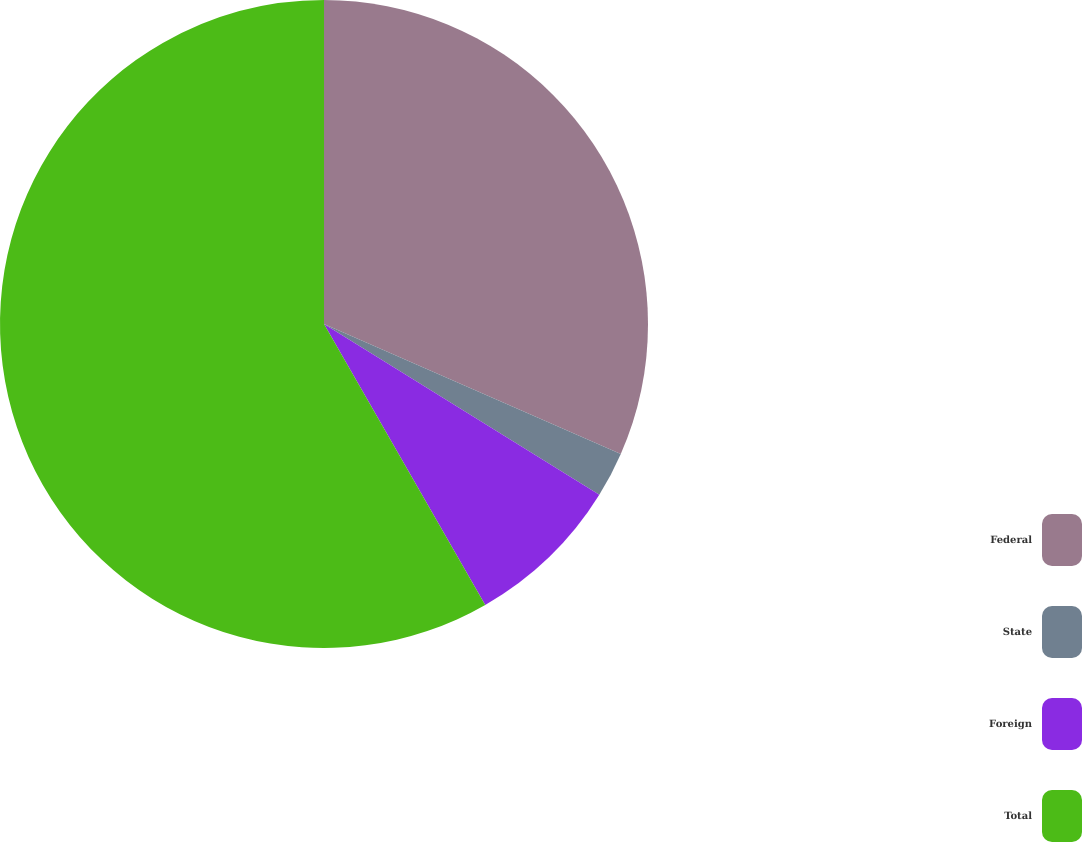Convert chart. <chart><loc_0><loc_0><loc_500><loc_500><pie_chart><fcel>Federal<fcel>State<fcel>Foreign<fcel>Total<nl><fcel>31.57%<fcel>2.27%<fcel>7.87%<fcel>58.29%<nl></chart> 